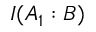<formula> <loc_0><loc_0><loc_500><loc_500>I ( A _ { 1 } \colon B )</formula> 